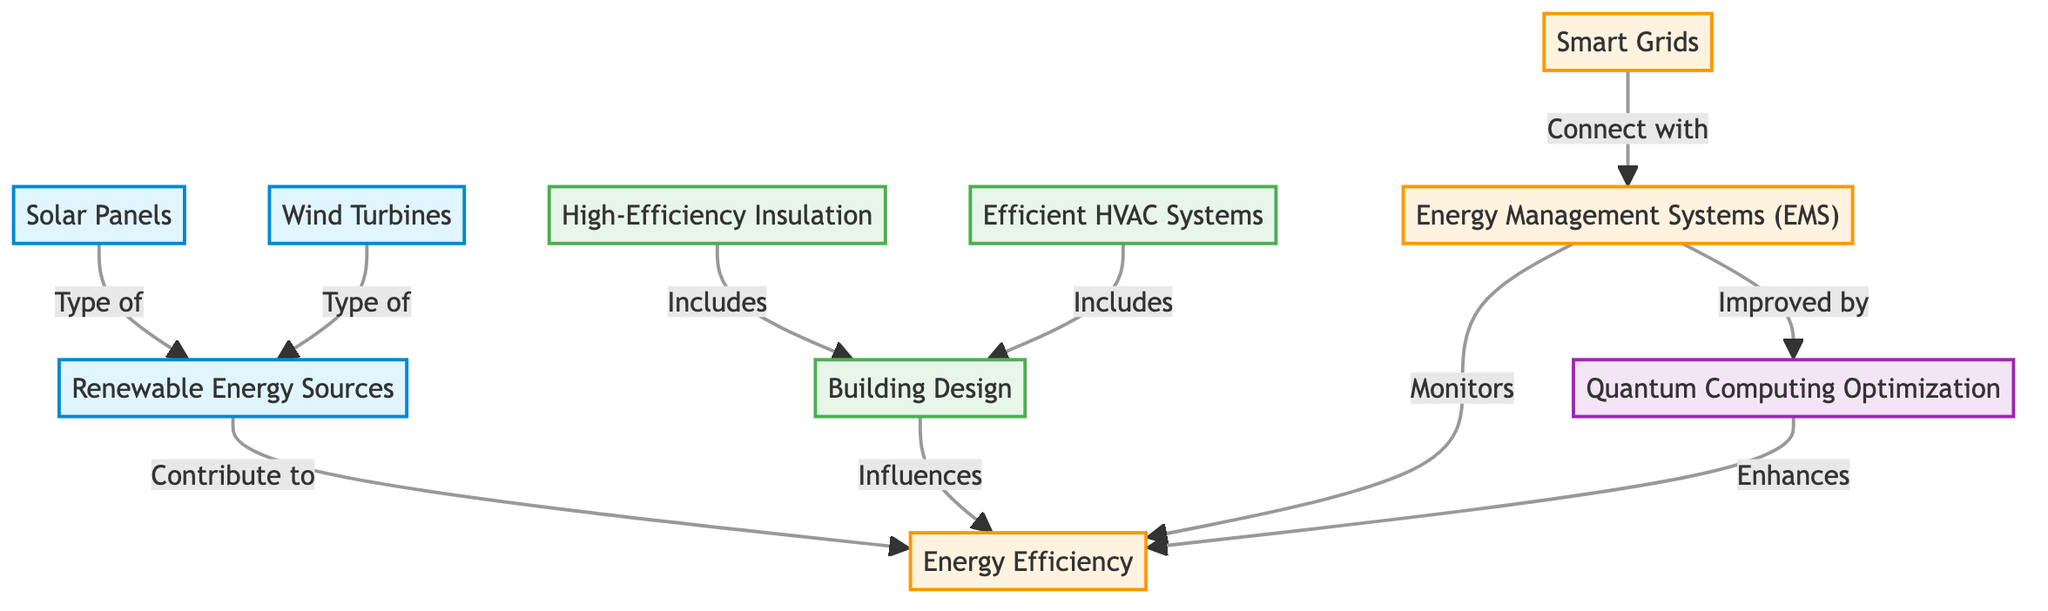What is the node that connects renewable energy sources to energy efficiency? The diagram indicates a connection between "Renewable Energy Sources" and "Energy Efficiency," symbolizing that renewable energy sources contribute to improving energy efficiency. This is shown with an arrow pointing from the renewable energy sources node to the energy efficiency node.
Answer: Energy Efficiency How many types of renewable energy sources are mentioned in the diagram? The diagram specifically lists two types of renewable energy sources: "Solar Panels" and "Wind Turbines." Each is a separate node under the "Renewable Energy Sources," which indicates their classification. Hence, we count both nodes.
Answer: 2 What influences energy efficiency according to the diagram? The diagram illustrates that "Building Design" is a key influencing factor on "Energy Efficiency." An arrow points from the building design node to the energy efficiency node, demonstrating the impact of building design on energy efficiency.
Answer: Building Design Which systems are improved by quantum computing optimization? The diagram shows that "Energy Management Systems (EMS)" are enhanced by "Quantum Computing Optimization." An arrow directs from the quantum computing optimization node to the energy management systems node, indicating this improvement.
Answer: Energy Management Systems (EMS) What type of systems monitors energy efficiency in eco-friendly buildings? The diagram indicates that "Energy Management Systems (EMS)" monitor energy efficiency. This is depicted with an arrow from the energy management systems node to the energy efficiency node, showing the monitoring relationship.
Answer: Energy Management Systems (EMS) What are the two main categories of components involved in energy efficiency? According to the diagram, the two main categories are "Renewable Energy Sources" and "Building Design." Each of these categories contributes differently to energy efficiency, with distinct nodes illustrated in the diagram.
Answer: Renewable Energy Sources and Building Design Which renewable energy source is specifically mentioned as a panel? The diagram points out "Solar Panels" as a type of renewable energy source. It is listed directly under the renewable energy sources node, distinguishing it as a panel-type energy source.
Answer: Solar Panels What connects smart grids with energy management systems? The diagram shows a direct connection from "Smart Grids" to "Energy Management Systems (EMS)." This relationship illustrates that smart grids connect with energy management systems, highlighting their interdependence.
Answer: Energy Management Systems (EMS) 